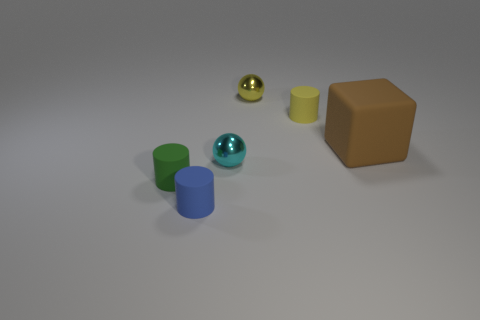What can you infer about the scale of the objects based on this image? The objects in the image appear to be quite small, likely decorative or educational models due to their size relations and the uniformity of the background. The precise scaling is difficult to ascertain without a reference point, but based on the shadows and perspective, they seem to be arranged on a flat surface, at a moderate distance from each other. The proportional differences between the objects, such as the tiny sphere next to the larger cylinders and cube, also give us clues about their relative sizes. 